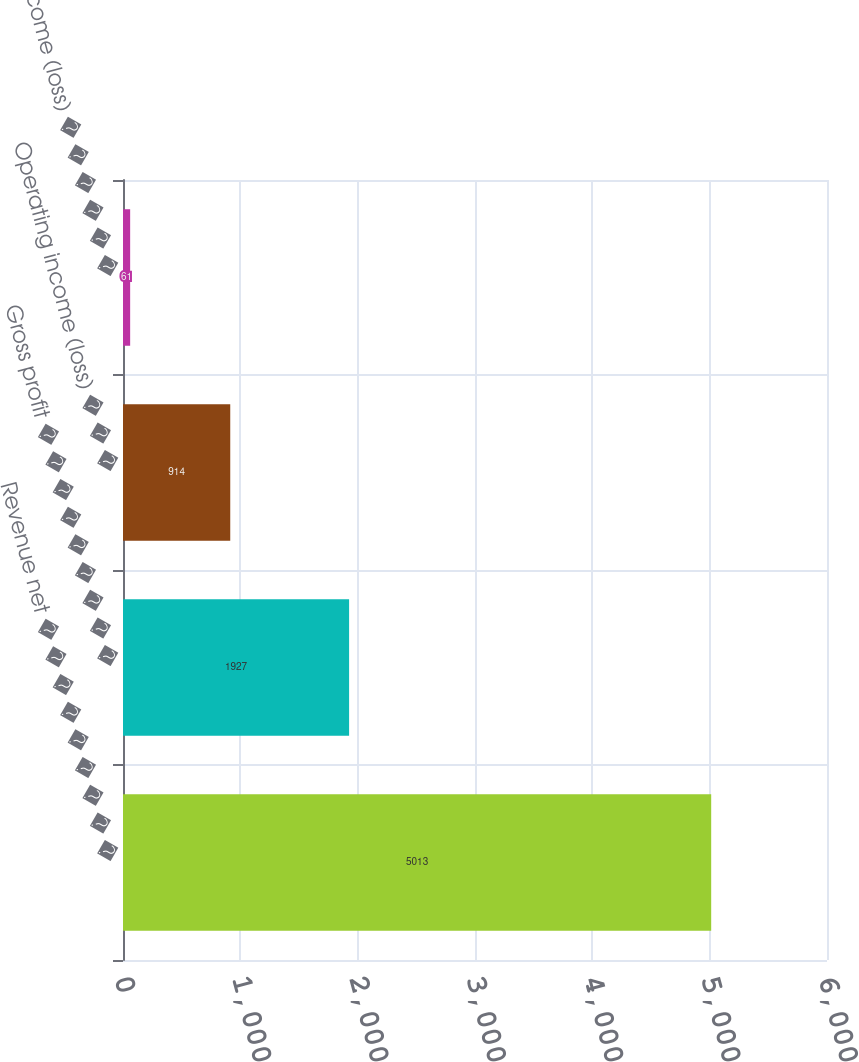Convert chart to OTSL. <chart><loc_0><loc_0><loc_500><loc_500><bar_chart><fcel>Revenue net � � � � � � � � �<fcel>Gross profit � � � � � � � � �<fcel>Operating income (loss) � � �<fcel>Net income (loss) � � � � � �<nl><fcel>5013<fcel>1927<fcel>914<fcel>61<nl></chart> 